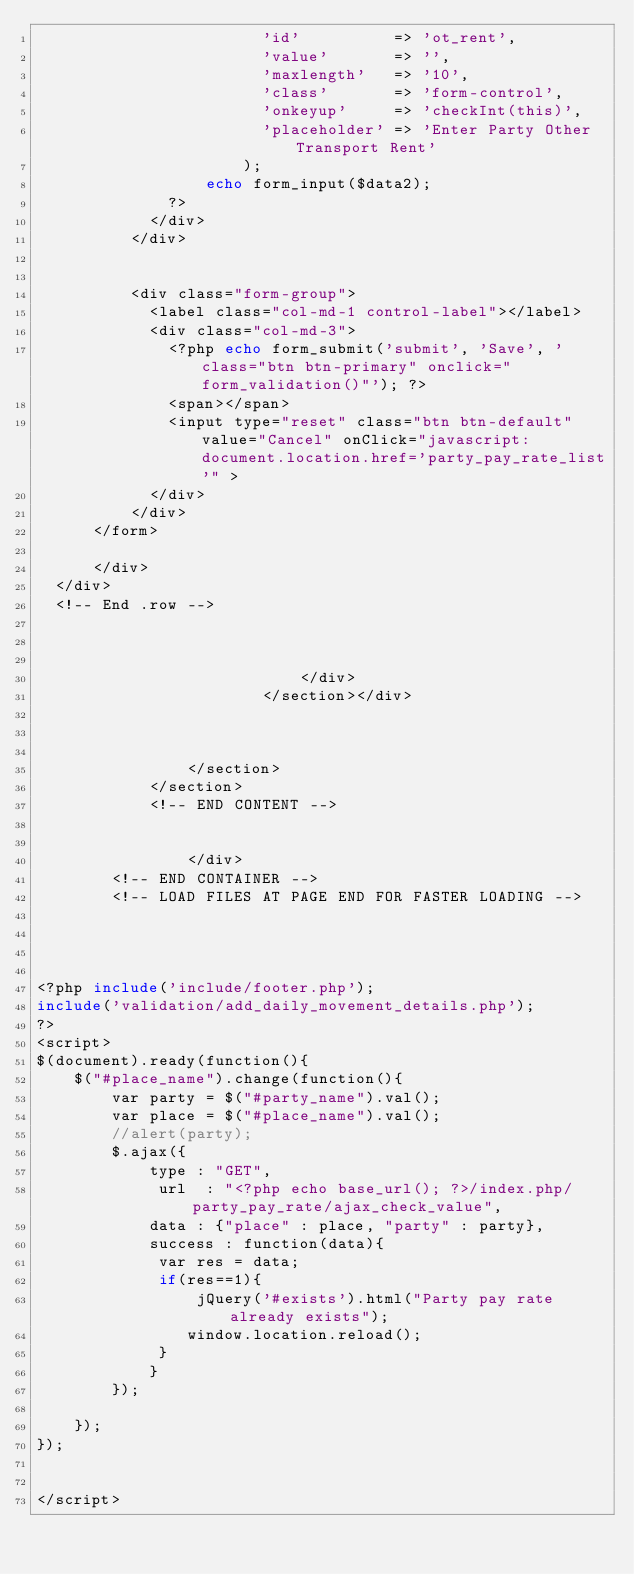Convert code to text. <code><loc_0><loc_0><loc_500><loc_500><_PHP_>                        'id'          => 'ot_rent',
                        'value'       => '',
                        'maxlength'   => '10',
                        'class'       => 'form-control',
                        'onkeyup'     => 'checkInt(this)',
						'placeholder' => 'Enter Party Other Transport Rent'
                      ); 
                  echo form_input($data2);
              ?>
            </div>
          </div>
           
            
          <div class="form-group">
            <label class="col-md-1 control-label"></label>
            <div class="col-md-3">              
              <?php echo form_submit('submit', 'Save', 'class="btn btn-primary" onclick="form_validation()"'); ?>
              <span></span>
              <input type="reset" class="btn btn-default" value="Cancel" onClick="javascript: document.location.href='party_pay_rate_list'" >
            </div>
          </div> 
      </form>
       
      </div>
  </div>
  <!-- End .row -->
  
  

                            </div>
                        </section></div>



                </section>
            </section>
            <!-- END CONTENT -->


                </div>
        <!-- END CONTAINER -->
        <!-- LOAD FILES AT PAGE END FOR FASTER LOADING -->

 


<?php include('include/footer.php');
include('validation/add_daily_movement_details.php');
?>
<script>
$(document).ready(function(){
	$("#place_name").change(function(){
		var party = $("#party_name").val();
		var place = $("#place_name").val();
		//alert(party);
		$.ajax({
			type : "GET",
			 url  : "<?php echo base_url(); ?>/index.php/party_pay_rate/ajax_check_value",
			data : {"place" : place, "party" : party},
			success : function(data){
			 var res = data;
			 if(res==1){
				 jQuery('#exists').html("Party pay rate already exists");
				window.location.reload();
			 }
			}
		});
			
	});		
});
	

</script>
        </code> 